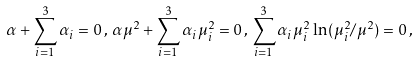Convert formula to latex. <formula><loc_0><loc_0><loc_500><loc_500>\alpha + \sum _ { i = 1 } ^ { 3 } \alpha _ { i } = 0 \, , \, \alpha \mu ^ { 2 } + \sum _ { i = 1 } ^ { 3 } \alpha _ { i } \mu _ { i } ^ { 2 } = 0 \, , \, \sum _ { i = 1 } ^ { 3 } \alpha _ { i } \mu _ { i } ^ { 2 } \ln ( \mu _ { i } ^ { 2 } / \mu ^ { 2 } ) = 0 \, ,</formula> 